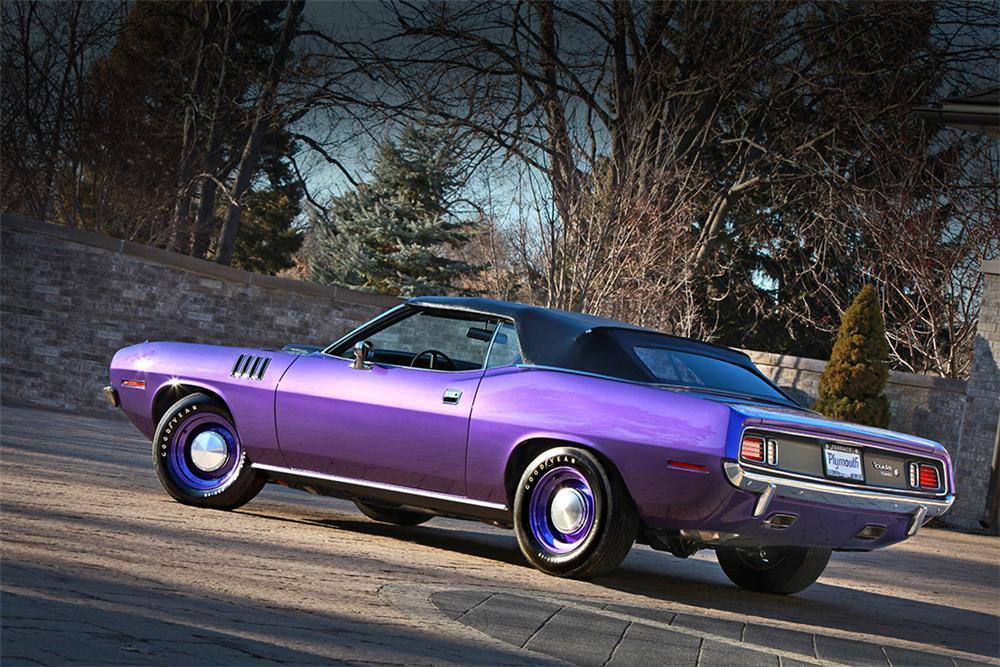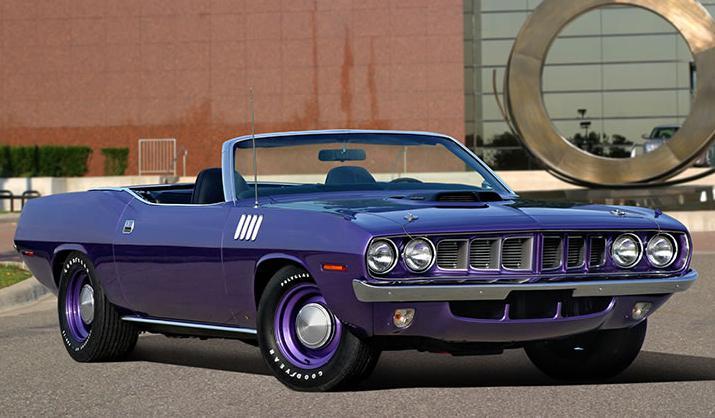The first image is the image on the left, the second image is the image on the right. For the images displayed, is the sentence "There are two cars that are the same color, but one has the top down while the other has its top up" factually correct? Answer yes or no. Yes. 